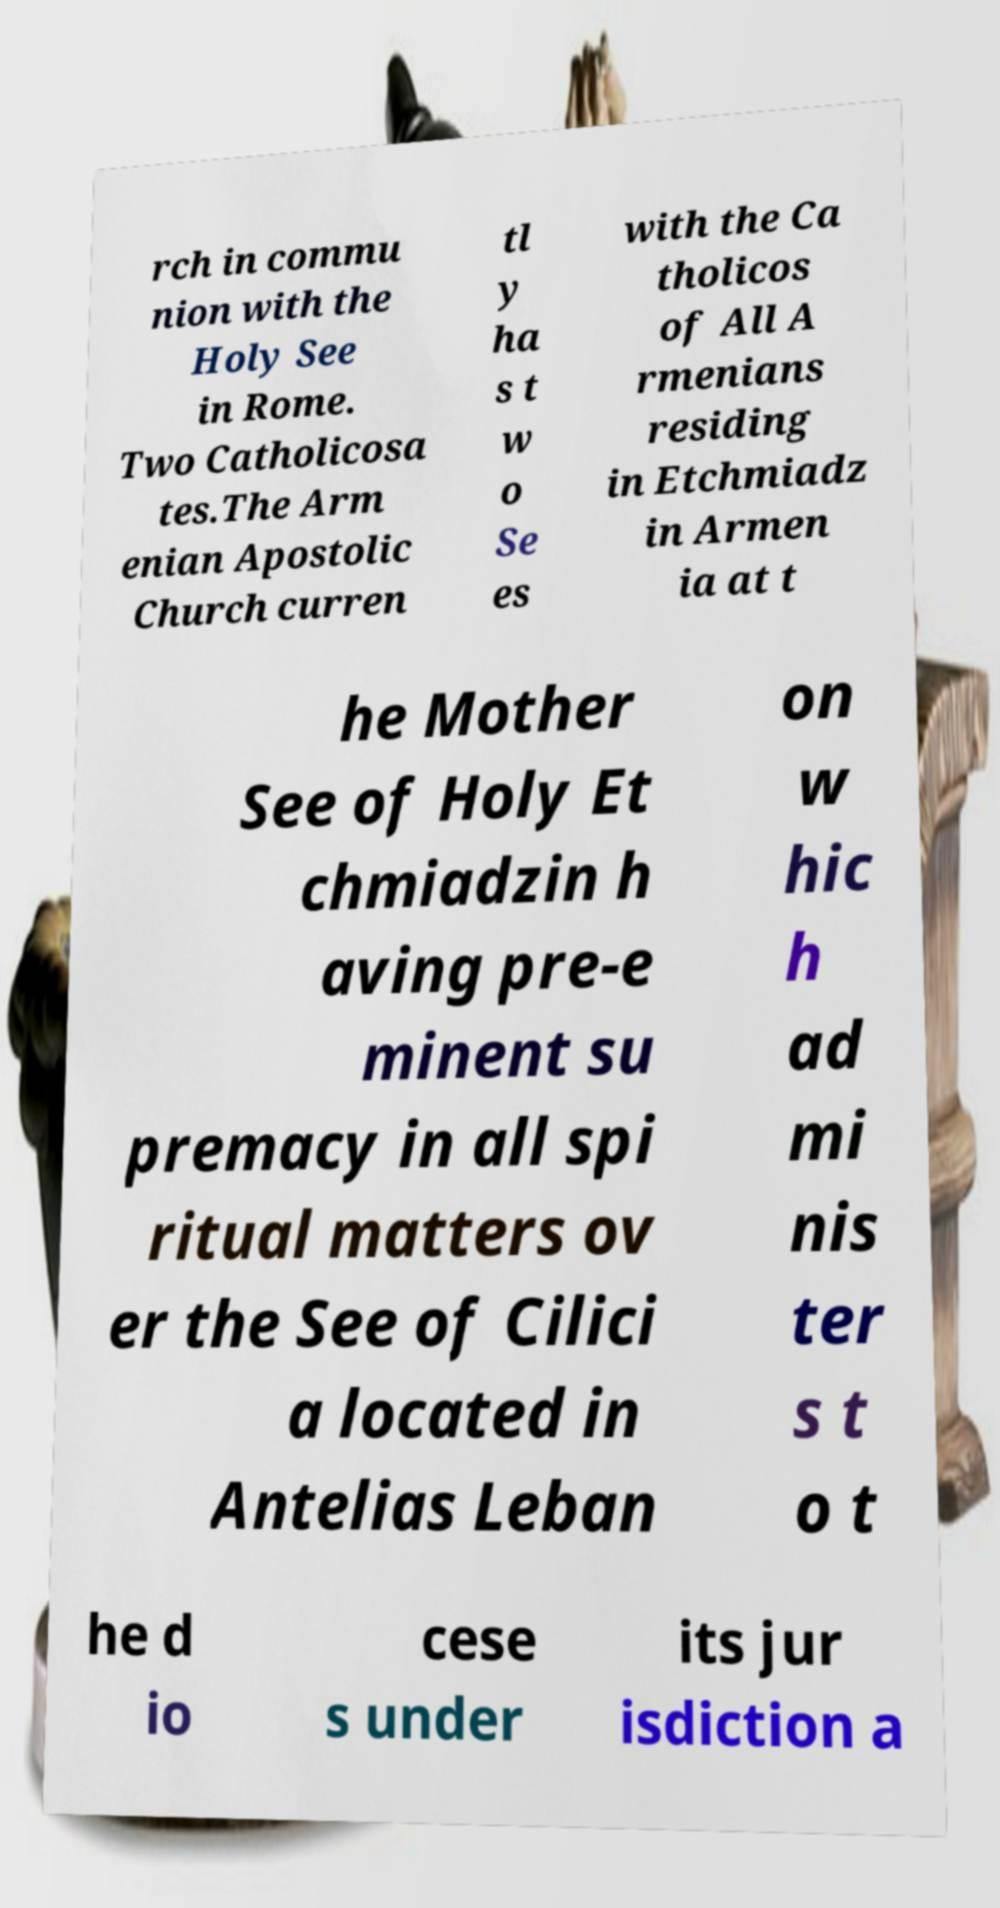I need the written content from this picture converted into text. Can you do that? rch in commu nion with the Holy See in Rome. Two Catholicosa tes.The Arm enian Apostolic Church curren tl y ha s t w o Se es with the Ca tholicos of All A rmenians residing in Etchmiadz in Armen ia at t he Mother See of Holy Et chmiadzin h aving pre-e minent su premacy in all spi ritual matters ov er the See of Cilici a located in Antelias Leban on w hic h ad mi nis ter s t o t he d io cese s under its jur isdiction a 